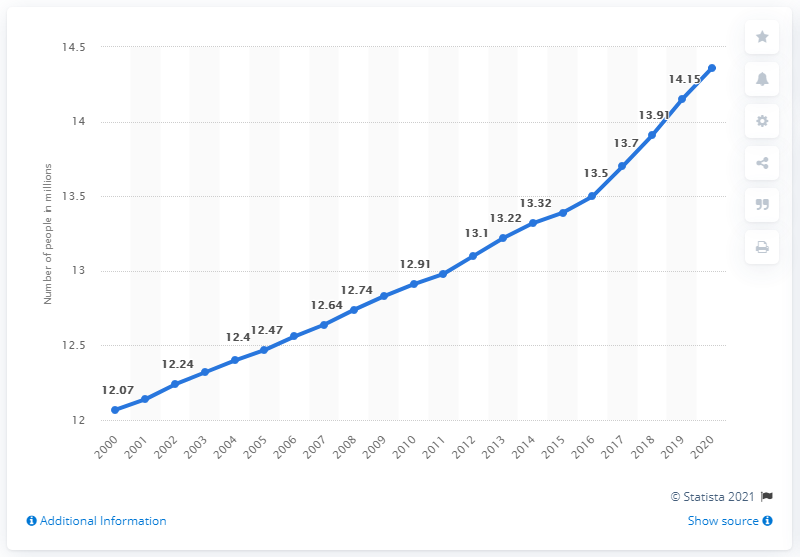Mention a couple of crucial points in this snapshot. In 2000, there were approximately 12.14 million married individuals living in Canada. In 2020, it was estimated that approximately 14.36% of the population of Canada was married. 